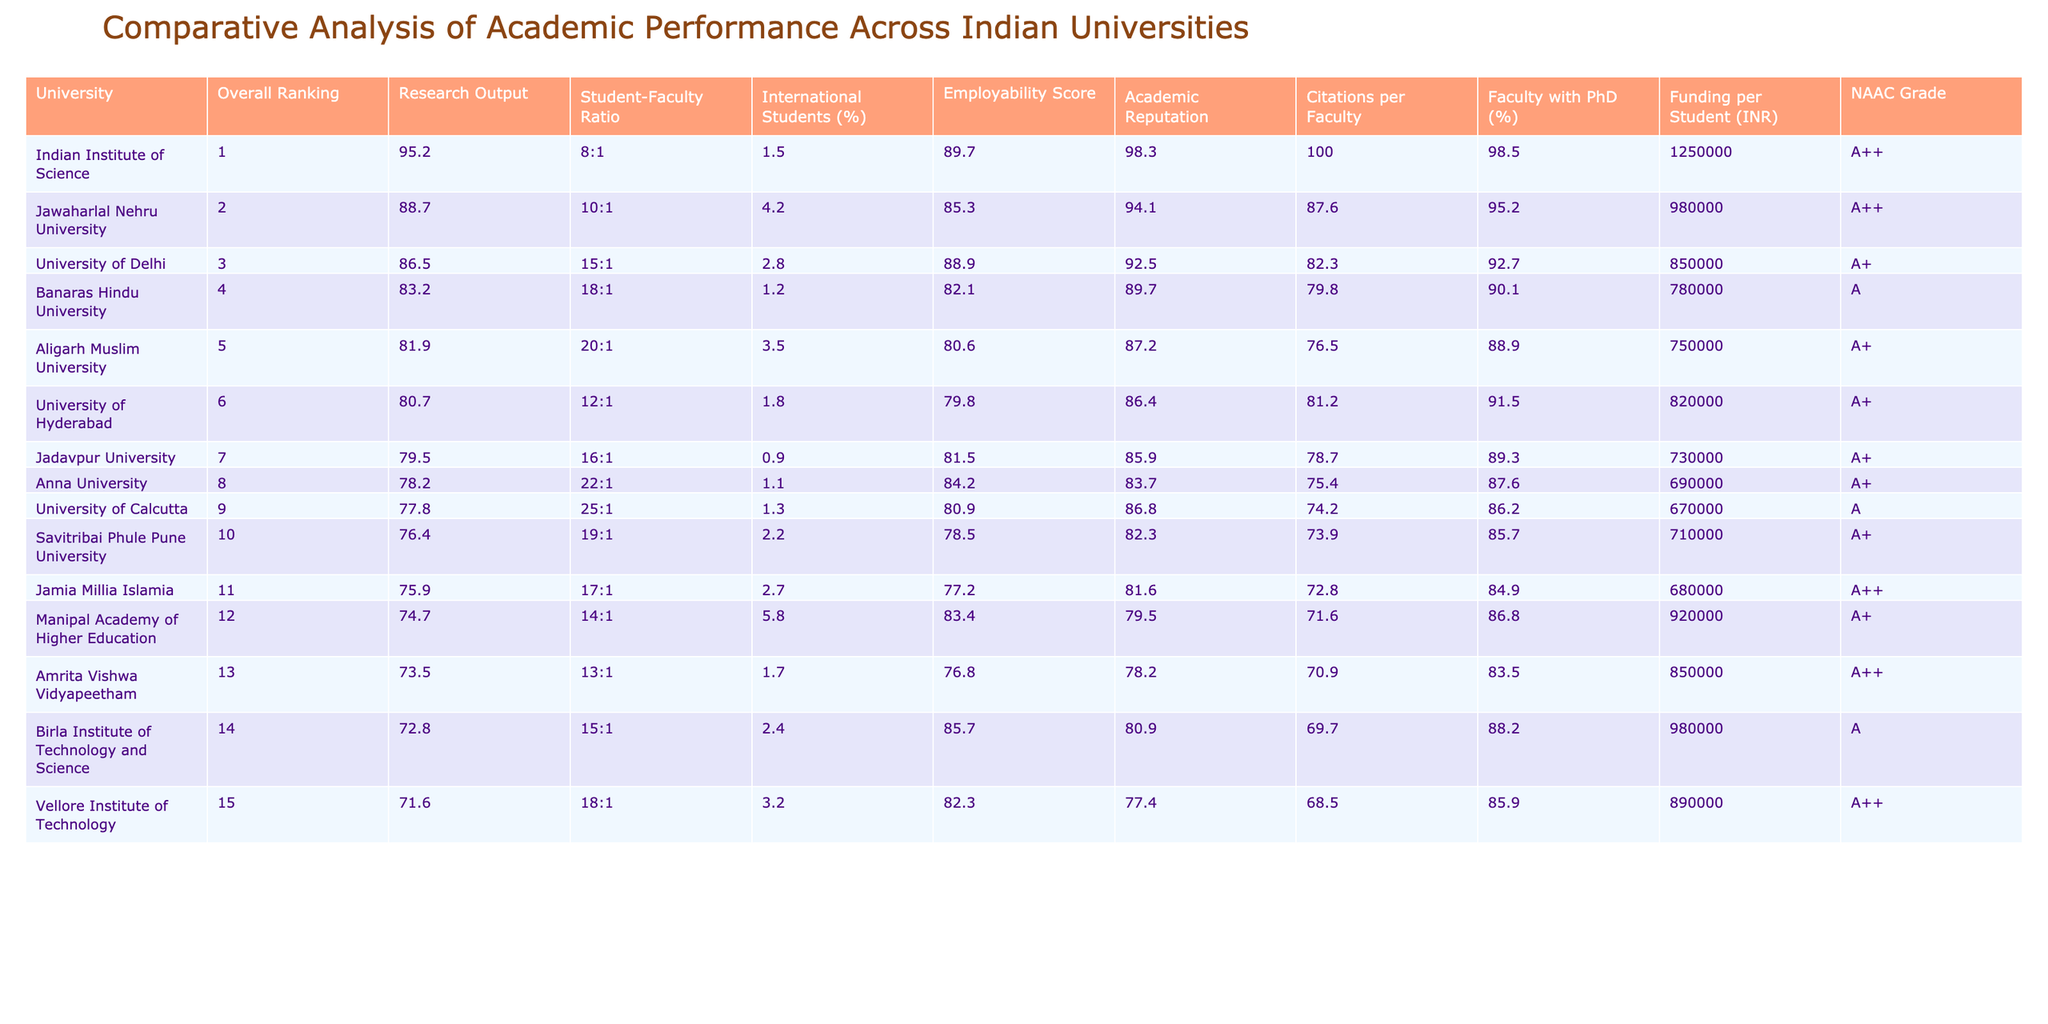What university has the highest employability score? The employability scores are listed under the "Employability Score" column. Scanning down this column, the Indian Institute of Science has the highest score at 89.7.
Answer: Indian Institute of Science How many universities have a NAAC grade of A++? By counting the entries under the "NAAC Grade" column, we see A++ appears for four universities: Indian Institute of Science, Jawaharlal Nehru University, Jamia Millia Islamia, and Vellore Institute of Technology.
Answer: 4 Which university has the lowest research output? The "Research Output" values indicate that Vellore Institute of Technology has the lowest score at 71.6 after checking the full column for the smallest number.
Answer: Vellore Institute of Technology What is the average student-faculty ratio of the top three universities? The ratios for the top three universities are 8:1, 10:1, and 15:1. To find the average, we convert them to fractions (1/8, 1/10, 1/15) and calculate: (1/8 + 1/10 + 1/15) = (15 + 12 + 8) / 120 = 35/120 = 7/24. The average ratio is therefore approximately 3.43:1.
Answer: 3.43:1 True or False: University of Delhi has a higher citation per faculty score than Banaras Hindu University. The "Citations per Faculty" column shows University of Delhi at 82.3 and Banaras Hindu University at 79.8. Since 82.3 is greater than 79.8, the statement is true.
Answer: True What is the difference in research output between the University of Hyderabad and Aligarh Muslim University? The research output for the University of Hyderabad is 80.7 and for Aligarh Muslim University it’s 81.9. The difference is calculated as 81.9 - 80.7 = 1.2.
Answer: 1.2 Which university has the highest percentage of international students? Checking the "International Students (%)" column, we find Manipal Academy of Higher Education has the highest percentage at 5.8%.
Answer: Manipal Academy of Higher Education List the universities that have a student-faculty ratio less than 15:1. A review of the "Student-Faculty Ratio" column shows that Indian Institute of Science (8:1), Jawaharlal Nehru University (10:1), University of Hyderabad (12:1), and Manipal Academy of Higher Education (14:1) meet this criterion.
Answer: Indian Institute of Science, Jawaharlal Nehru University, University of Hyderabad, Manipal Academy of Higher Education What is the overall ranking of the university with the highest funding per student? The "Funding per Student (INR)" column indicates that the Indian Institute of Science has the highest funding at 1,250,000 INR. Its overall ranking is 1.
Answer: 1 How many universities have a student-faculty ratio of 20:1 or higher? By examining the "Student-Faculty Ratio" column, we find that Aligarh Muslim University (20:1), Anna University (22:1), and University of Calcutta (25:1) meet the criteria. This gives us a total of three.
Answer: 3 What is the total funding per student for the top five universities combined? The funding per student for the top five universities are 1,250,000, 980,000, 850,000, 780,000, and 750,000. Adding these gives 1,250,000 + 980,000 + 850,000 + 780,000 + 750,000 = 3,610,000 INR.
Answer: 3,610,000 INR 